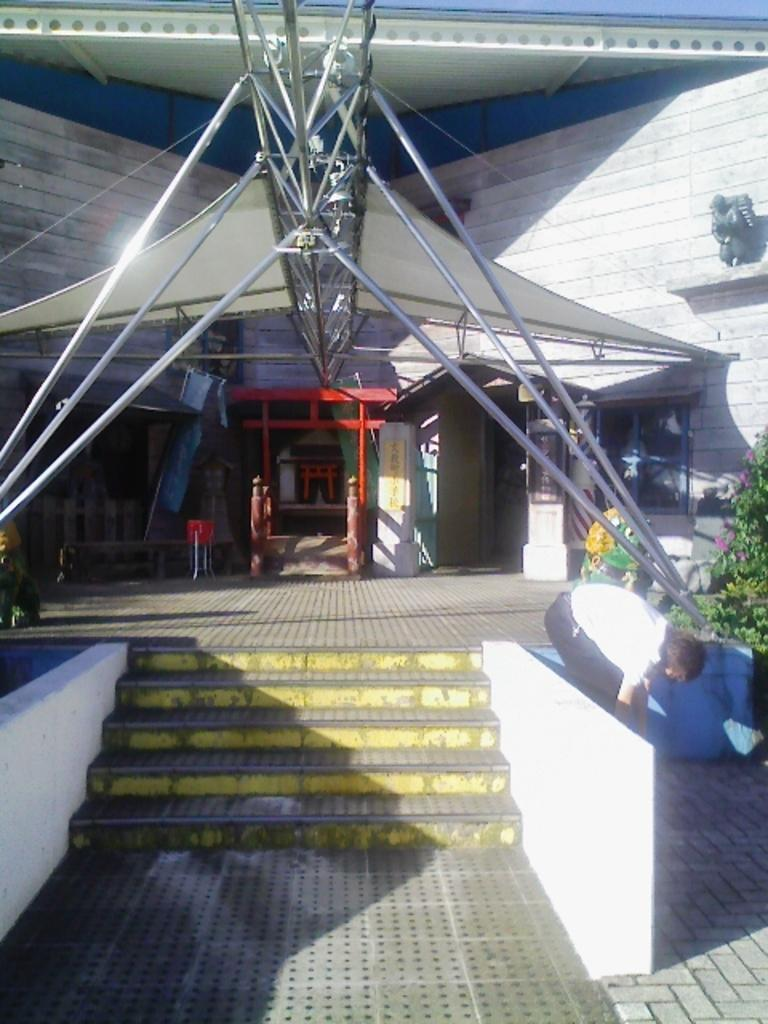What can be seen in the foreground of the image? There are steps in the foreground of the image. What structure is visible in the image? There is: There is a building in the image. What type of vegetation is on the right side of the image? There are plants on the right side of the image. Can you describe the person in the image? There is a person in the image. What is the ground made of in the image? The ground has tiles in the image. What else can be seen in the image besides the steps, building, plants, and person? There are poles in the image. Where is the drawer located in the image? There is no drawer present in the image. What type of grass can be seen growing near the person in the image? There is no grass visible in the image; the ground has tiles. 